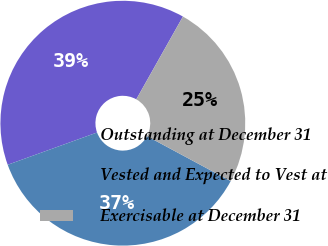Convert chart. <chart><loc_0><loc_0><loc_500><loc_500><pie_chart><fcel>Outstanding at December 31<fcel>Vested and Expected to Vest at<fcel>Exercisable at December 31<nl><fcel>38.68%<fcel>36.64%<fcel>24.67%<nl></chart> 